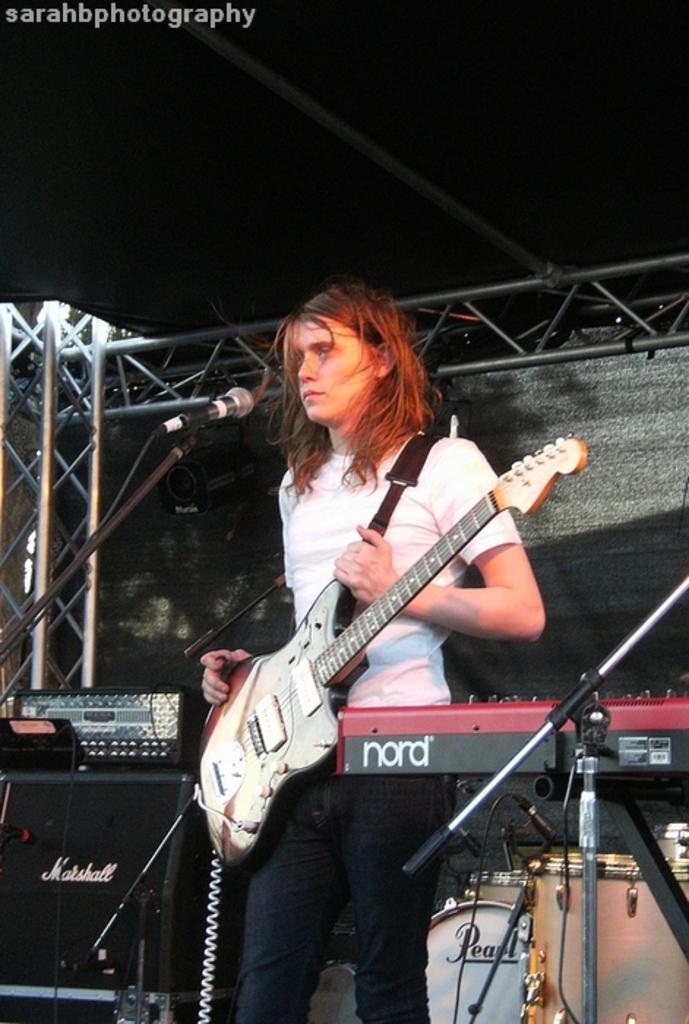Describe this image in one or two sentences. In this image we can see a woman standing in front of a mike and holding a guitar. Here we can see musical instruments, poles, and rods. There is a dark background. At the top of the image we can see some text. 